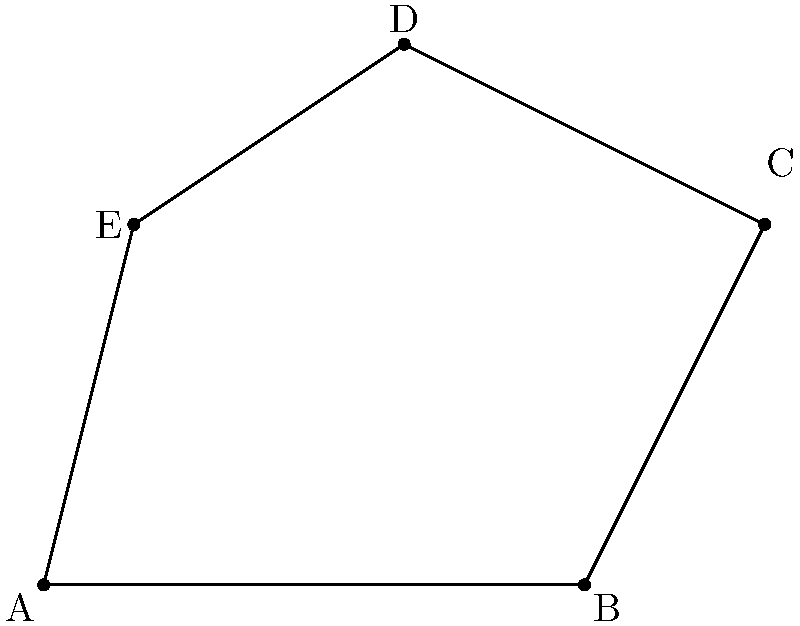As a conference coordinator planning a personal development seminar on work-life harmony, you want to use a visual representation of balance. You've created a polygon on a coordinate system to illustrate this concept. Calculate the area of the polygon ABCDE given the following coordinates: A(0,0), B(6,0), C(8,4), D(4,6), and E(1,4). Round your answer to the nearest whole number. To calculate the area of the irregular polygon ABCDE, we can use the Shoelace formula (also known as the surveyor's formula). The steps are as follows:

1) The Shoelace formula for a polygon with vertices $(x_1, y_1), (x_2, y_2), ..., (x_n, y_n)$ is:

   Area = $\frac{1}{2}|(x_1y_2 + x_2y_3 + ... + x_ny_1) - (y_1x_2 + y_2x_3 + ... + y_nx_1)|$

2) Substituting our coordinates:
   A(0,0), B(6,0), C(8,4), D(4,6), E(1,4)

3) Applying the formula:

   Area = $\frac{1}{2}|[(0 \cdot 0 + 6 \cdot 4 + 8 \cdot 6 + 4 \cdot 4 + 1 \cdot 0) - (0 \cdot 6 + 0 \cdot 8 + 4 \cdot 4 + 6 \cdot 1 + 4 \cdot 0)]|$

4) Simplifying:

   Area = $\frac{1}{2}|[(0 + 24 + 48 + 16 + 0) - (0 + 0 + 16 + 6 + 0)]|$
   
   Area = $\frac{1}{2}|[88 - 22]|$
   
   Area = $\frac{1}{2}|66|$
   
   Area = $33$

5) The question asks to round to the nearest whole number, but 33 is already a whole number.

Therefore, the area of the polygon is 33 square units.
Answer: 33 square units 